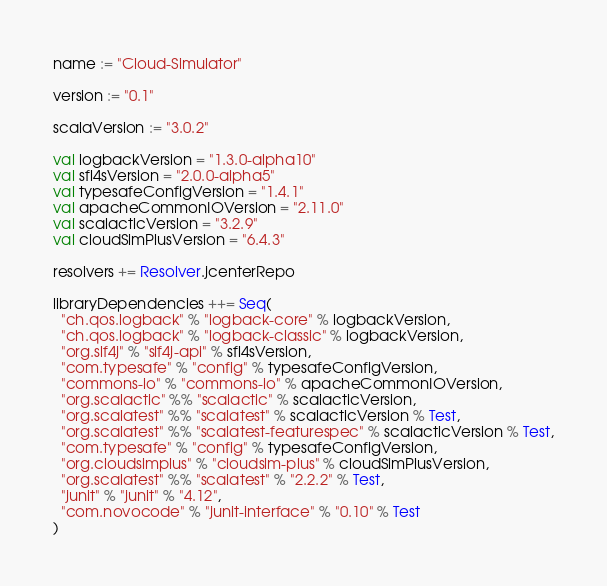Convert code to text. <code><loc_0><loc_0><loc_500><loc_500><_Scala_>name := "Cloud-Simulator"

version := "0.1"

scalaVersion := "3.0.2"

val logbackVersion = "1.3.0-alpha10"
val sfl4sVersion = "2.0.0-alpha5"
val typesafeConfigVersion = "1.4.1"
val apacheCommonIOVersion = "2.11.0"
val scalacticVersion = "3.2.9"
val cloudSimPlusVersion = "6.4.3"

resolvers += Resolver.jcenterRepo

libraryDependencies ++= Seq(
  "ch.qos.logback" % "logback-core" % logbackVersion,
  "ch.qos.logback" % "logback-classic" % logbackVersion,
  "org.slf4j" % "slf4j-api" % sfl4sVersion,
  "com.typesafe" % "config" % typesafeConfigVersion,
  "commons-io" % "commons-io" % apacheCommonIOVersion,
  "org.scalactic" %% "scalactic" % scalacticVersion,
  "org.scalatest" %% "scalatest" % scalacticVersion % Test,
  "org.scalatest" %% "scalatest-featurespec" % scalacticVersion % Test,
  "com.typesafe" % "config" % typesafeConfigVersion,
  "org.cloudsimplus" % "cloudsim-plus" % cloudSimPlusVersion,
  "org.scalatest" %% "scalatest" % "2.2.2" % Test,
  "junit" % "junit" % "4.12",
  "com.novocode" % "junit-interface" % "0.10" % Test
)</code> 